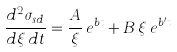Convert formula to latex. <formula><loc_0><loc_0><loc_500><loc_500>\frac { d ^ { 2 } \sigma _ { s d } } { d \xi \, d t } = \frac { A } { \xi } \, e ^ { b t } + B \, \xi \, e ^ { b ^ { \prime } t }</formula> 